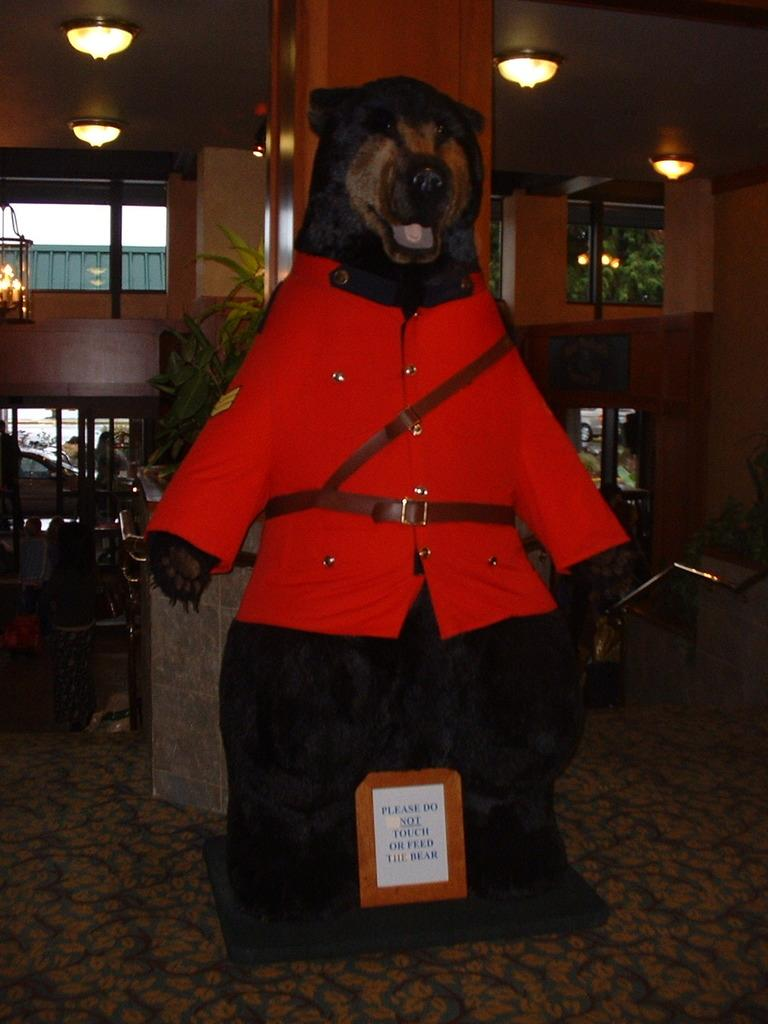What animal is present in the image? There is a dog in the image. What is the dog wearing? The dog is wearing a red shirt. What is below the dog? There is a board below the dog. Can you describe any structures in the image? There is a pillar in the image. What type of vegetation is visible in the image? There are plants in the image. What type of barrier is present in the image? There is a fence in the image. What is at the top of the image? There are lights at the top of the image. What type of notebook is the dog holding in the image? There is no notebook present in the image; the dog is wearing a red shirt and standing on a board. 